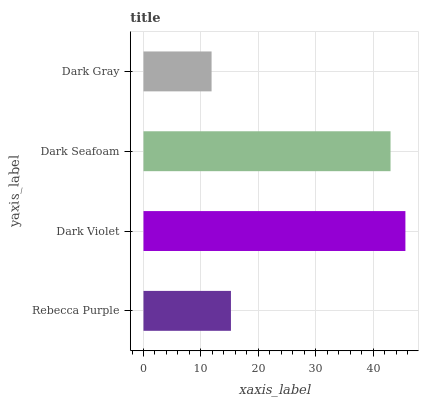Is Dark Gray the minimum?
Answer yes or no. Yes. Is Dark Violet the maximum?
Answer yes or no. Yes. Is Dark Seafoam the minimum?
Answer yes or no. No. Is Dark Seafoam the maximum?
Answer yes or no. No. Is Dark Violet greater than Dark Seafoam?
Answer yes or no. Yes. Is Dark Seafoam less than Dark Violet?
Answer yes or no. Yes. Is Dark Seafoam greater than Dark Violet?
Answer yes or no. No. Is Dark Violet less than Dark Seafoam?
Answer yes or no. No. Is Dark Seafoam the high median?
Answer yes or no. Yes. Is Rebecca Purple the low median?
Answer yes or no. Yes. Is Dark Gray the high median?
Answer yes or no. No. Is Dark Violet the low median?
Answer yes or no. No. 